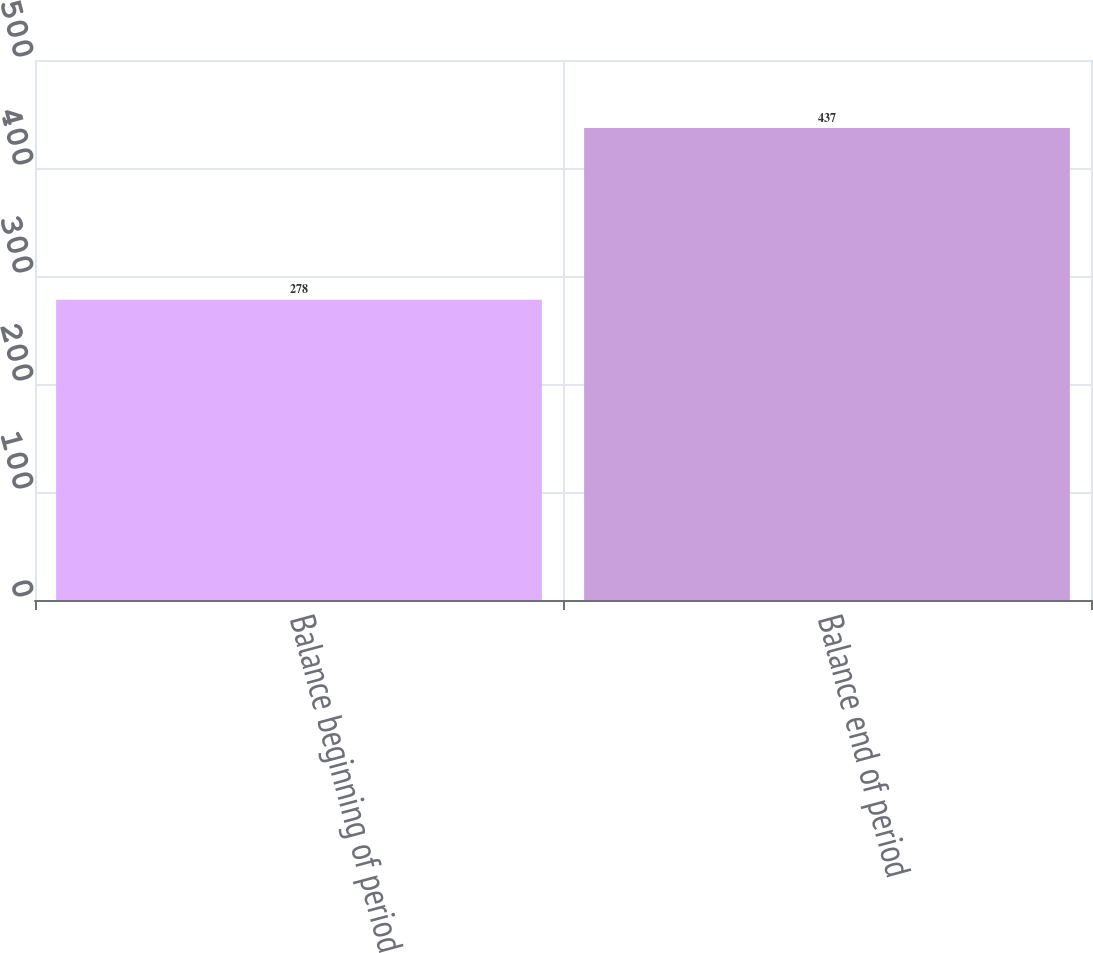<chart> <loc_0><loc_0><loc_500><loc_500><bar_chart><fcel>Balance beginning of period<fcel>Balance end of period<nl><fcel>278<fcel>437<nl></chart> 